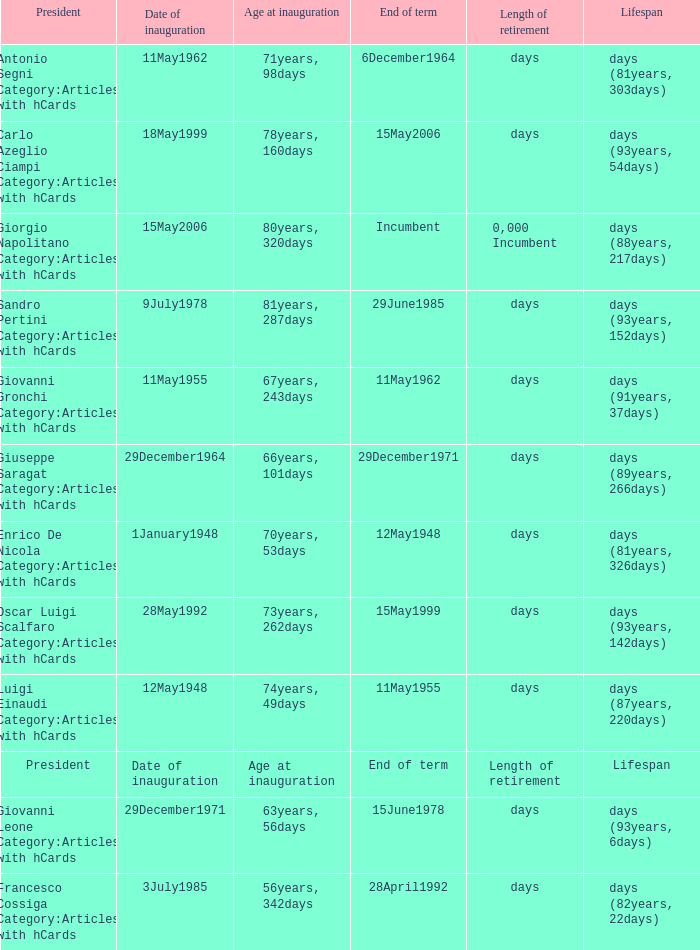What is the Date of inauguration of the President with an Age at inauguration of 73years, 262days? 28May1992. 